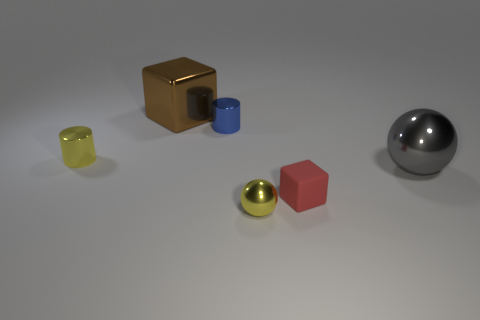Add 4 red cubes. How many objects exist? 10 Subtract all blocks. How many objects are left? 4 Add 1 large balls. How many large balls exist? 2 Subtract 0 blue blocks. How many objects are left? 6 Subtract all tiny green metal objects. Subtract all small cylinders. How many objects are left? 4 Add 1 yellow spheres. How many yellow spheres are left? 2 